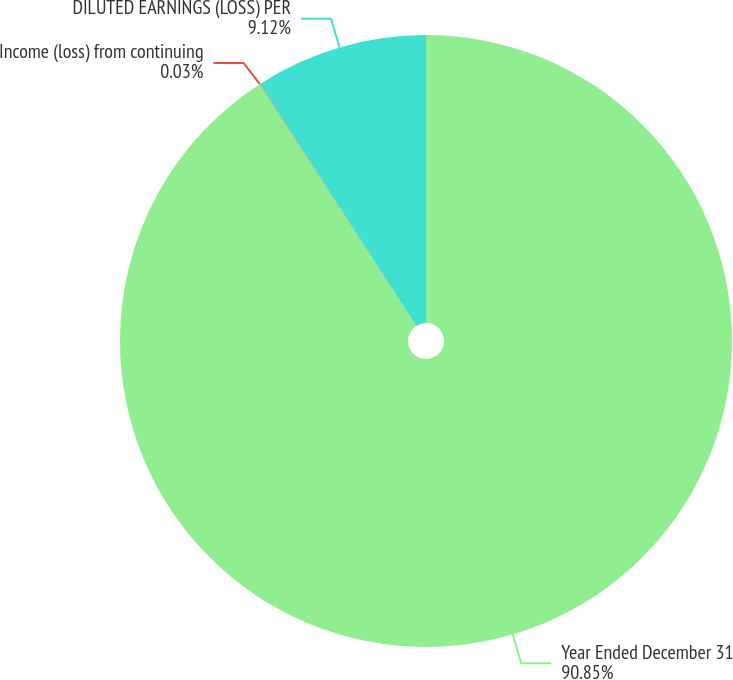<chart> <loc_0><loc_0><loc_500><loc_500><pie_chart><fcel>Year Ended December 31<fcel>Income (loss) from continuing<fcel>DILUTED EARNINGS (LOSS) PER<nl><fcel>90.85%<fcel>0.03%<fcel>9.12%<nl></chart> 